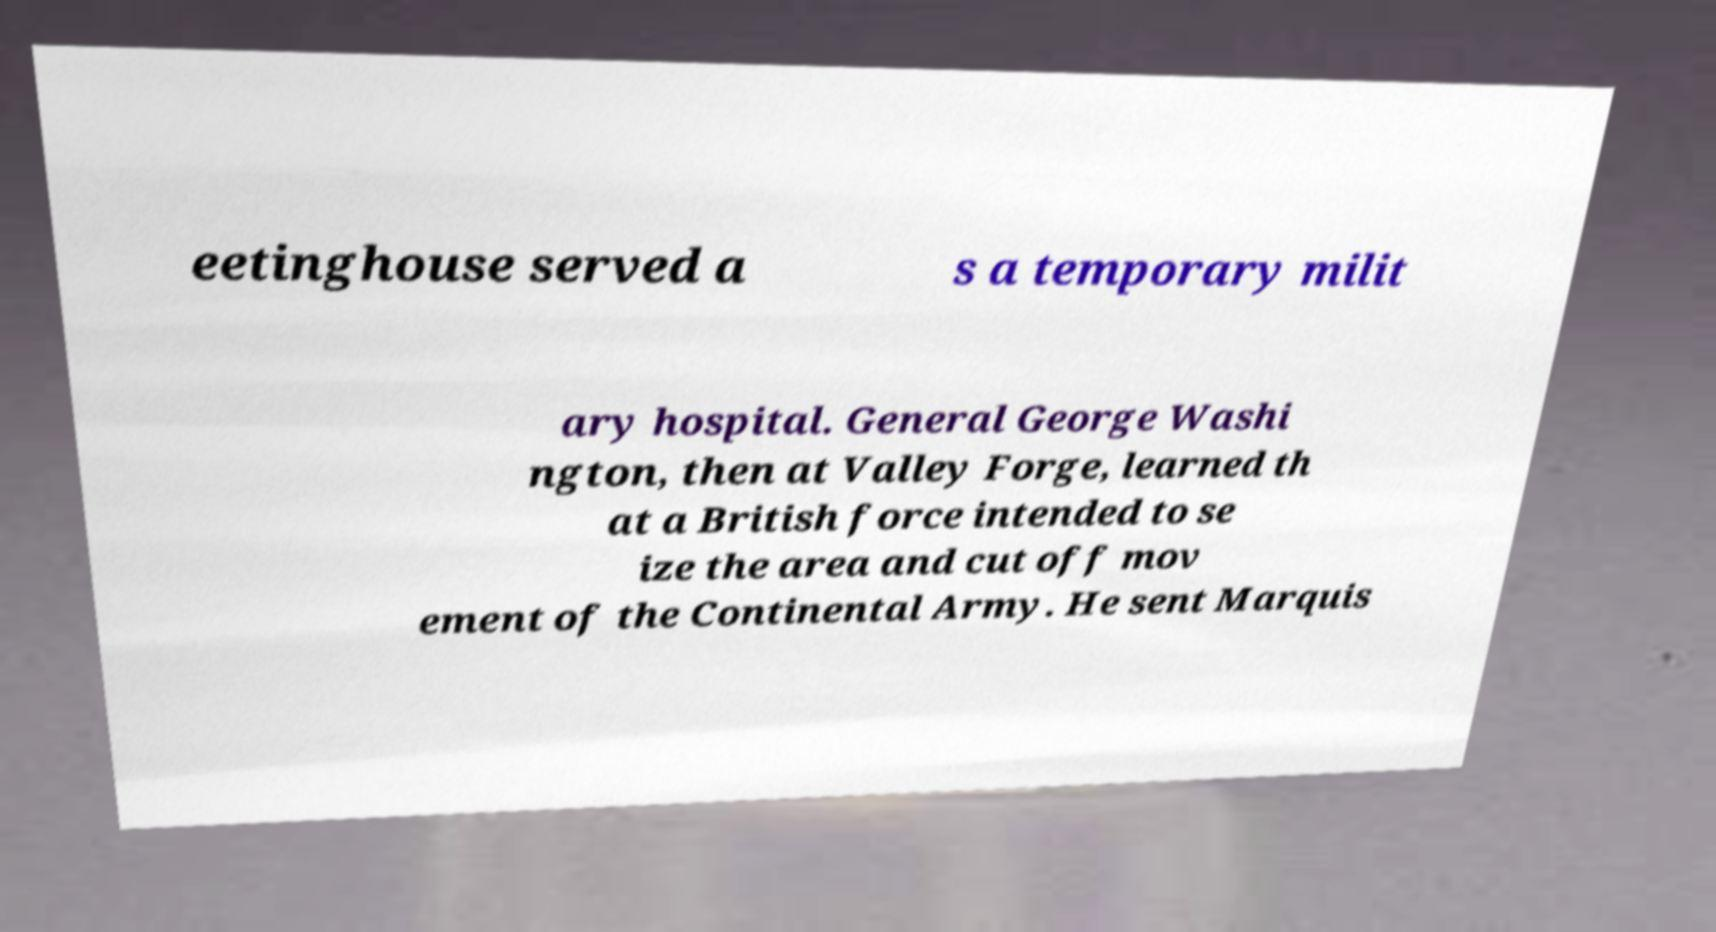Can you read and provide the text displayed in the image?This photo seems to have some interesting text. Can you extract and type it out for me? eetinghouse served a s a temporary milit ary hospital. General George Washi ngton, then at Valley Forge, learned th at a British force intended to se ize the area and cut off mov ement of the Continental Army. He sent Marquis 